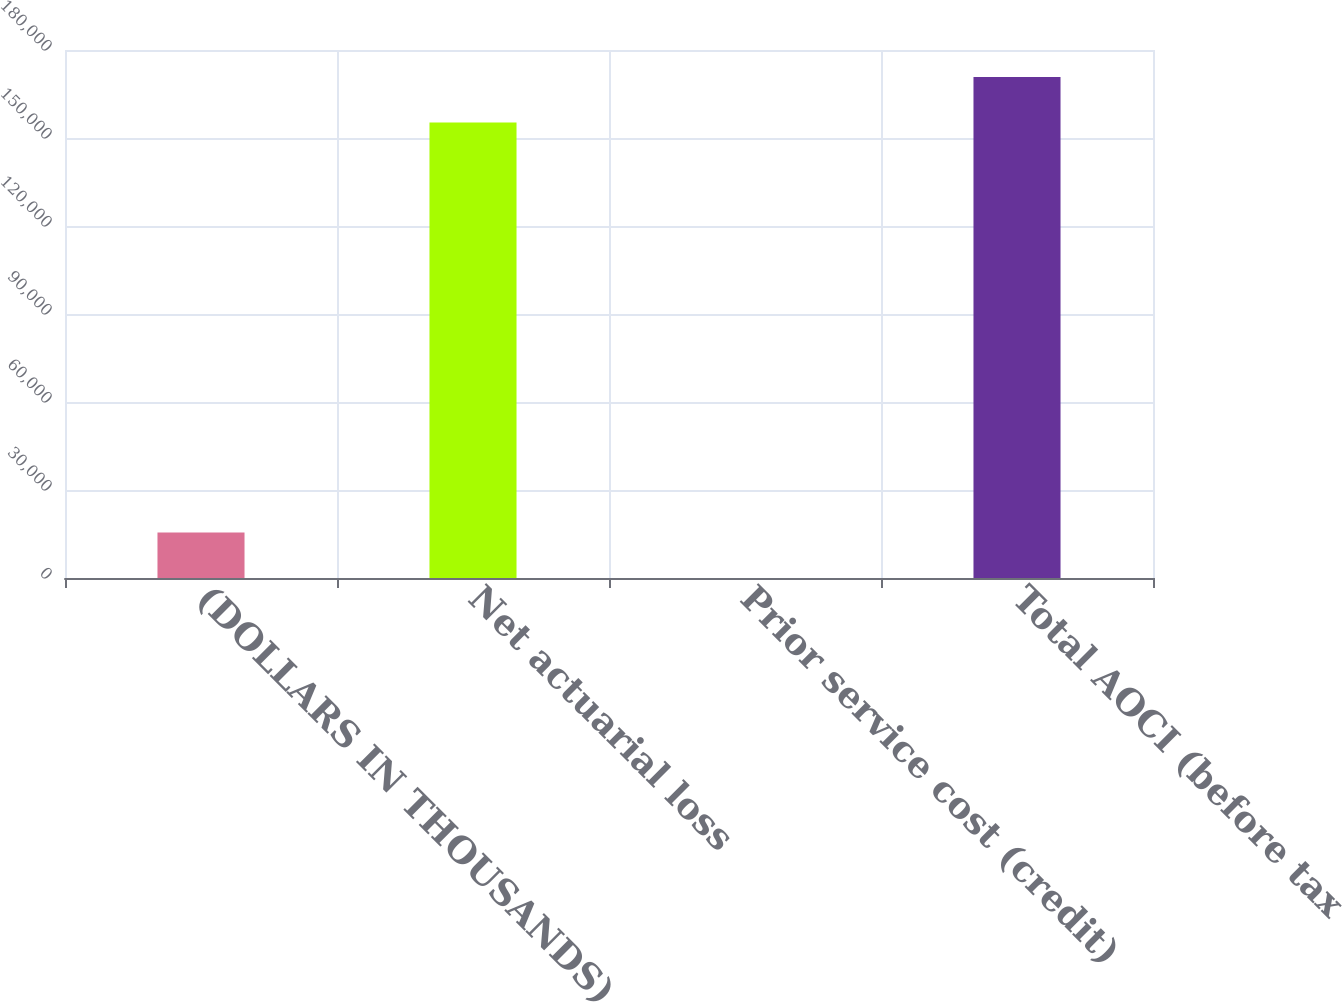<chart> <loc_0><loc_0><loc_500><loc_500><bar_chart><fcel>(DOLLARS IN THOUSANDS)<fcel>Net actuarial loss<fcel>Prior service cost (credit)<fcel>Total AOCI (before tax<nl><fcel>15547.5<fcel>155305<fcel>17<fcel>170836<nl></chart> 